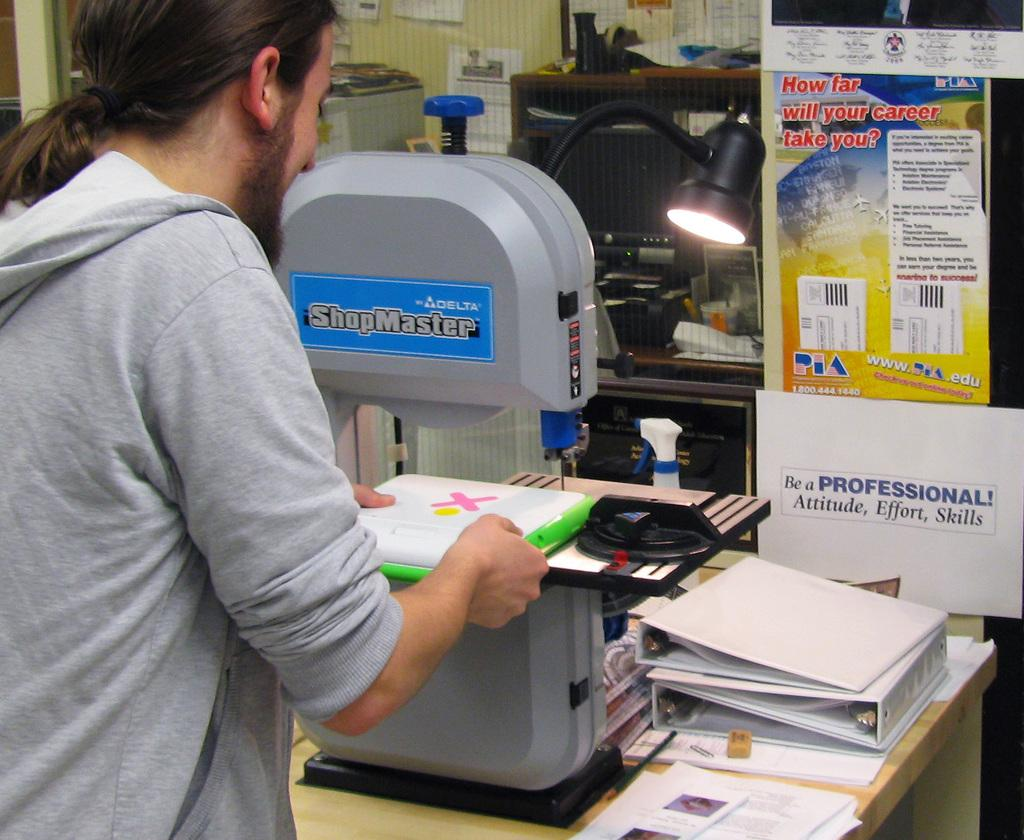<image>
Offer a succinct explanation of the picture presented. Person using a ShopMaster sewing machine while holding something. 